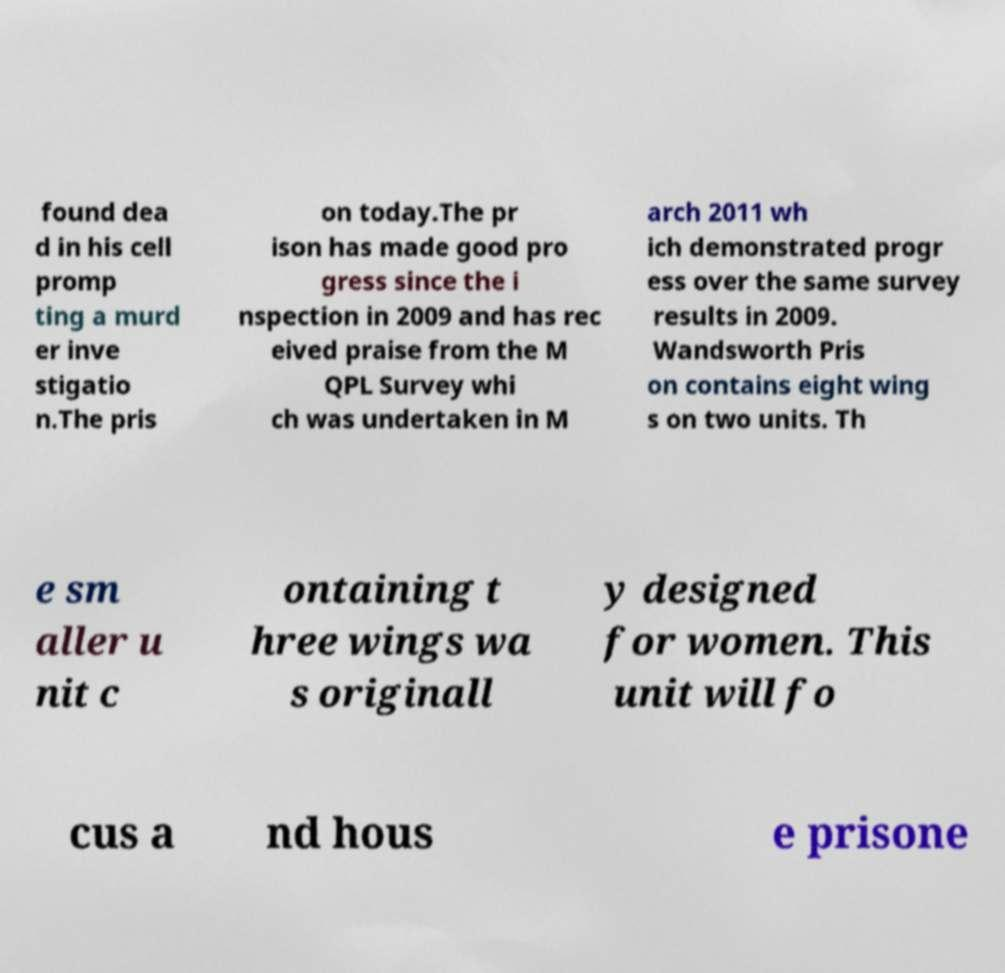Could you assist in decoding the text presented in this image and type it out clearly? found dea d in his cell promp ting a murd er inve stigatio n.The pris on today.The pr ison has made good pro gress since the i nspection in 2009 and has rec eived praise from the M QPL Survey whi ch was undertaken in M arch 2011 wh ich demonstrated progr ess over the same survey results in 2009. Wandsworth Pris on contains eight wing s on two units. Th e sm aller u nit c ontaining t hree wings wa s originall y designed for women. This unit will fo cus a nd hous e prisone 